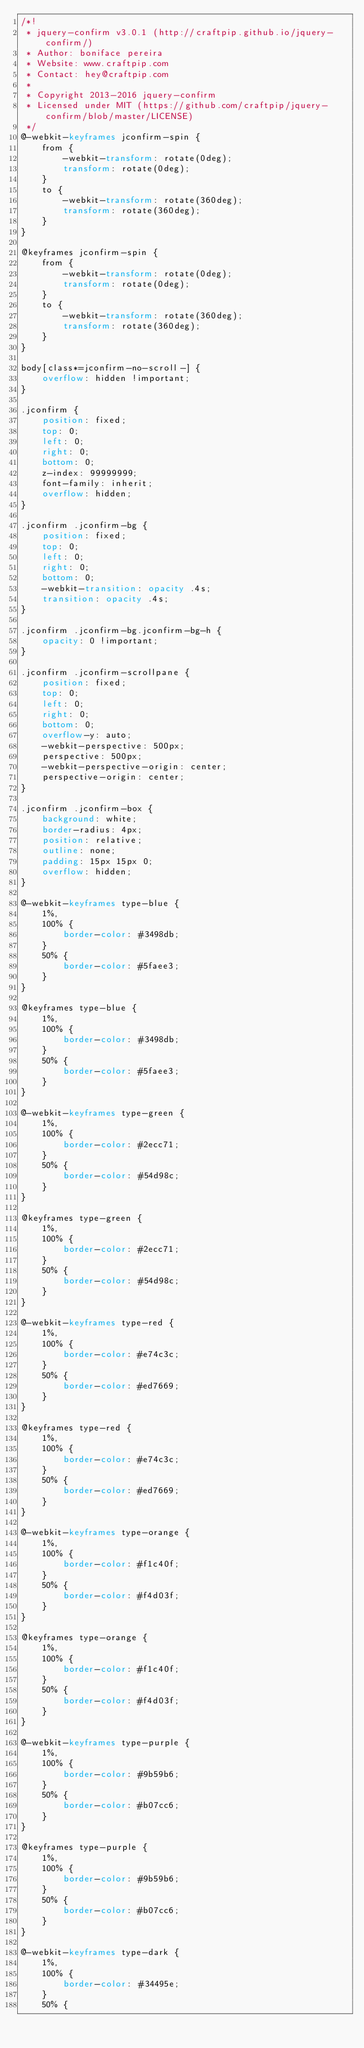Convert code to text. <code><loc_0><loc_0><loc_500><loc_500><_CSS_>/*!
 * jquery-confirm v3.0.1 (http://craftpip.github.io/jquery-confirm/)
 * Author: boniface pereira
 * Website: www.craftpip.com
 * Contact: hey@craftpip.com
 *
 * Copyright 2013-2016 jquery-confirm
 * Licensed under MIT (https://github.com/craftpip/jquery-confirm/blob/master/LICENSE)
 */
@-webkit-keyframes jconfirm-spin {
    from {
        -webkit-transform: rotate(0deg);
        transform: rotate(0deg);
    }
    to {
        -webkit-transform: rotate(360deg);
        transform: rotate(360deg);
    }
}

@keyframes jconfirm-spin {
    from {
        -webkit-transform: rotate(0deg);
        transform: rotate(0deg);
    }
    to {
        -webkit-transform: rotate(360deg);
        transform: rotate(360deg);
    }
}

body[class*=jconfirm-no-scroll-] {
    overflow: hidden !important;
}

.jconfirm {
    position: fixed;
    top: 0;
    left: 0;
    right: 0;
    bottom: 0;
    z-index: 99999999;
    font-family: inherit;
    overflow: hidden;
}

.jconfirm .jconfirm-bg {
    position: fixed;
    top: 0;
    left: 0;
    right: 0;
    bottom: 0;
    -webkit-transition: opacity .4s;
    transition: opacity .4s;
}

.jconfirm .jconfirm-bg.jconfirm-bg-h {
    opacity: 0 !important;
}

.jconfirm .jconfirm-scrollpane {
    position: fixed;
    top: 0;
    left: 0;
    right: 0;
    bottom: 0;
    overflow-y: auto;
    -webkit-perspective: 500px;
    perspective: 500px;
    -webkit-perspective-origin: center;
    perspective-origin: center;
}

.jconfirm .jconfirm-box {
    background: white;
    border-radius: 4px;
    position: relative;
    outline: none;
    padding: 15px 15px 0;
    overflow: hidden;
}

@-webkit-keyframes type-blue {
    1%,
    100% {
        border-color: #3498db;
    }
    50% {
        border-color: #5faee3;
    }
}

@keyframes type-blue {
    1%,
    100% {
        border-color: #3498db;
    }
    50% {
        border-color: #5faee3;
    }
}

@-webkit-keyframes type-green {
    1%,
    100% {
        border-color: #2ecc71;
    }
    50% {
        border-color: #54d98c;
    }
}

@keyframes type-green {
    1%,
    100% {
        border-color: #2ecc71;
    }
    50% {
        border-color: #54d98c;
    }
}

@-webkit-keyframes type-red {
    1%,
    100% {
        border-color: #e74c3c;
    }
    50% {
        border-color: #ed7669;
    }
}

@keyframes type-red {
    1%,
    100% {
        border-color: #e74c3c;
    }
    50% {
        border-color: #ed7669;
    }
}

@-webkit-keyframes type-orange {
    1%,
    100% {
        border-color: #f1c40f;
    }
    50% {
        border-color: #f4d03f;
    }
}

@keyframes type-orange {
    1%,
    100% {
        border-color: #f1c40f;
    }
    50% {
        border-color: #f4d03f;
    }
}

@-webkit-keyframes type-purple {
    1%,
    100% {
        border-color: #9b59b6;
    }
    50% {
        border-color: #b07cc6;
    }
}

@keyframes type-purple {
    1%,
    100% {
        border-color: #9b59b6;
    }
    50% {
        border-color: #b07cc6;
    }
}

@-webkit-keyframes type-dark {
    1%,
    100% {
        border-color: #34495e;
    }
    50% {</code> 